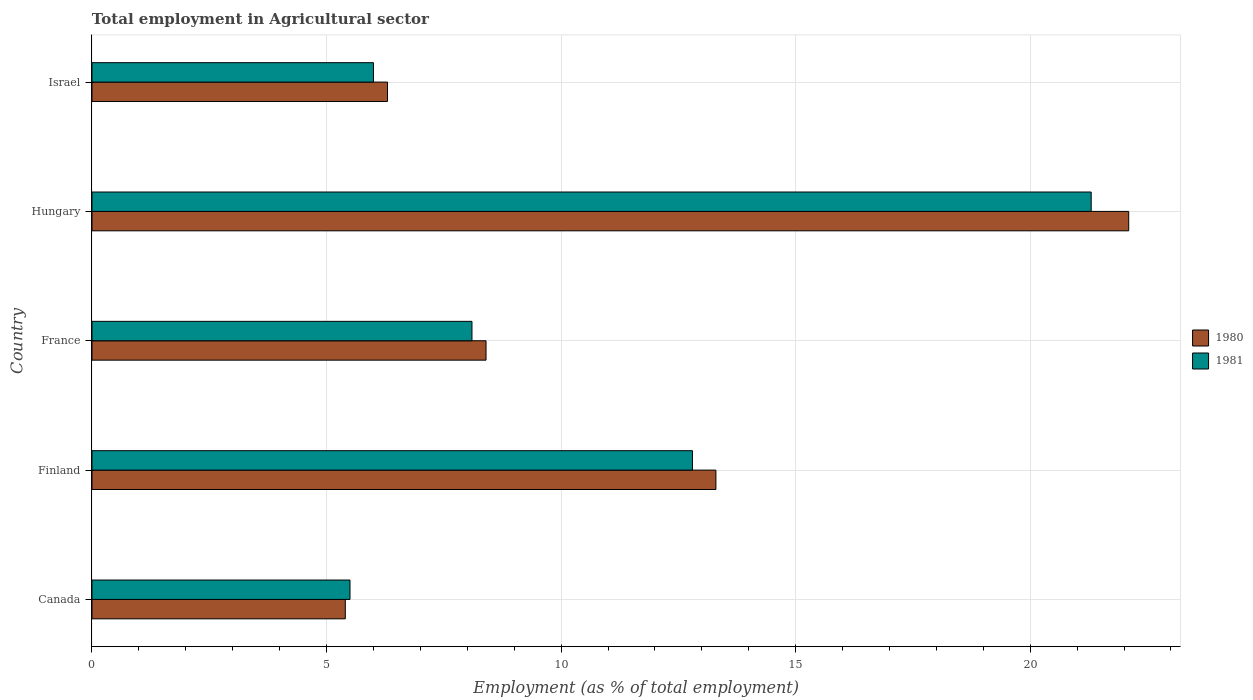How many different coloured bars are there?
Your answer should be very brief. 2. What is the label of the 4th group of bars from the top?
Give a very brief answer. Finland. In how many cases, is the number of bars for a given country not equal to the number of legend labels?
Make the answer very short. 0. What is the employment in agricultural sector in 1981 in Finland?
Give a very brief answer. 12.8. Across all countries, what is the maximum employment in agricultural sector in 1981?
Provide a short and direct response. 21.3. In which country was the employment in agricultural sector in 1981 maximum?
Ensure brevity in your answer.  Hungary. What is the total employment in agricultural sector in 1981 in the graph?
Make the answer very short. 53.7. What is the difference between the employment in agricultural sector in 1981 in France and that in Israel?
Give a very brief answer. 2.1. What is the difference between the employment in agricultural sector in 1980 in Finland and the employment in agricultural sector in 1981 in Hungary?
Provide a succinct answer. -8. What is the average employment in agricultural sector in 1981 per country?
Provide a short and direct response. 10.74. What is the difference between the employment in agricultural sector in 1980 and employment in agricultural sector in 1981 in France?
Provide a short and direct response. 0.3. What is the ratio of the employment in agricultural sector in 1981 in Finland to that in Israel?
Your answer should be very brief. 2.13. What is the difference between the highest and the second highest employment in agricultural sector in 1981?
Ensure brevity in your answer.  8.5. What is the difference between the highest and the lowest employment in agricultural sector in 1981?
Provide a succinct answer. 15.8. Is the sum of the employment in agricultural sector in 1980 in Canada and Israel greater than the maximum employment in agricultural sector in 1981 across all countries?
Make the answer very short. No. What does the 2nd bar from the top in France represents?
Give a very brief answer. 1980. What does the 2nd bar from the bottom in France represents?
Keep it short and to the point. 1981. Are all the bars in the graph horizontal?
Ensure brevity in your answer.  Yes. How many countries are there in the graph?
Make the answer very short. 5. Where does the legend appear in the graph?
Keep it short and to the point. Center right. How many legend labels are there?
Your answer should be compact. 2. What is the title of the graph?
Provide a short and direct response. Total employment in Agricultural sector. Does "1963" appear as one of the legend labels in the graph?
Provide a succinct answer. No. What is the label or title of the X-axis?
Give a very brief answer. Employment (as % of total employment). What is the label or title of the Y-axis?
Offer a terse response. Country. What is the Employment (as % of total employment) in 1980 in Canada?
Give a very brief answer. 5.4. What is the Employment (as % of total employment) of 1981 in Canada?
Keep it short and to the point. 5.5. What is the Employment (as % of total employment) of 1980 in Finland?
Your answer should be very brief. 13.3. What is the Employment (as % of total employment) in 1981 in Finland?
Provide a short and direct response. 12.8. What is the Employment (as % of total employment) of 1980 in France?
Provide a short and direct response. 8.4. What is the Employment (as % of total employment) of 1981 in France?
Your response must be concise. 8.1. What is the Employment (as % of total employment) of 1980 in Hungary?
Provide a short and direct response. 22.1. What is the Employment (as % of total employment) of 1981 in Hungary?
Your response must be concise. 21.3. What is the Employment (as % of total employment) in 1980 in Israel?
Keep it short and to the point. 6.3. Across all countries, what is the maximum Employment (as % of total employment) in 1980?
Your answer should be compact. 22.1. Across all countries, what is the maximum Employment (as % of total employment) of 1981?
Offer a terse response. 21.3. Across all countries, what is the minimum Employment (as % of total employment) in 1980?
Provide a short and direct response. 5.4. What is the total Employment (as % of total employment) of 1980 in the graph?
Make the answer very short. 55.5. What is the total Employment (as % of total employment) in 1981 in the graph?
Offer a very short reply. 53.7. What is the difference between the Employment (as % of total employment) of 1980 in Canada and that in Finland?
Your response must be concise. -7.9. What is the difference between the Employment (as % of total employment) of 1981 in Canada and that in France?
Your answer should be very brief. -2.6. What is the difference between the Employment (as % of total employment) in 1980 in Canada and that in Hungary?
Keep it short and to the point. -16.7. What is the difference between the Employment (as % of total employment) of 1981 in Canada and that in Hungary?
Offer a very short reply. -15.8. What is the difference between the Employment (as % of total employment) of 1980 in Canada and that in Israel?
Ensure brevity in your answer.  -0.9. What is the difference between the Employment (as % of total employment) in 1981 in Canada and that in Israel?
Your answer should be compact. -0.5. What is the difference between the Employment (as % of total employment) of 1980 in Finland and that in France?
Keep it short and to the point. 4.9. What is the difference between the Employment (as % of total employment) in 1981 in Finland and that in France?
Give a very brief answer. 4.7. What is the difference between the Employment (as % of total employment) in 1980 in Finland and that in Hungary?
Ensure brevity in your answer.  -8.8. What is the difference between the Employment (as % of total employment) of 1980 in Finland and that in Israel?
Provide a succinct answer. 7. What is the difference between the Employment (as % of total employment) in 1980 in France and that in Hungary?
Ensure brevity in your answer.  -13.7. What is the difference between the Employment (as % of total employment) of 1980 in France and that in Israel?
Provide a short and direct response. 2.1. What is the difference between the Employment (as % of total employment) in 1981 in France and that in Israel?
Offer a very short reply. 2.1. What is the difference between the Employment (as % of total employment) in 1980 in Canada and the Employment (as % of total employment) in 1981 in Finland?
Your response must be concise. -7.4. What is the difference between the Employment (as % of total employment) of 1980 in Canada and the Employment (as % of total employment) of 1981 in Hungary?
Provide a short and direct response. -15.9. What is the difference between the Employment (as % of total employment) in 1980 in Canada and the Employment (as % of total employment) in 1981 in Israel?
Ensure brevity in your answer.  -0.6. What is the difference between the Employment (as % of total employment) in 1980 in Hungary and the Employment (as % of total employment) in 1981 in Israel?
Offer a terse response. 16.1. What is the average Employment (as % of total employment) of 1980 per country?
Your answer should be compact. 11.1. What is the average Employment (as % of total employment) of 1981 per country?
Offer a very short reply. 10.74. What is the difference between the Employment (as % of total employment) of 1980 and Employment (as % of total employment) of 1981 in Canada?
Give a very brief answer. -0.1. What is the difference between the Employment (as % of total employment) of 1980 and Employment (as % of total employment) of 1981 in Finland?
Offer a very short reply. 0.5. What is the difference between the Employment (as % of total employment) in 1980 and Employment (as % of total employment) in 1981 in France?
Your answer should be compact. 0.3. What is the ratio of the Employment (as % of total employment) in 1980 in Canada to that in Finland?
Provide a short and direct response. 0.41. What is the ratio of the Employment (as % of total employment) of 1981 in Canada to that in Finland?
Offer a terse response. 0.43. What is the ratio of the Employment (as % of total employment) in 1980 in Canada to that in France?
Provide a short and direct response. 0.64. What is the ratio of the Employment (as % of total employment) of 1981 in Canada to that in France?
Offer a terse response. 0.68. What is the ratio of the Employment (as % of total employment) of 1980 in Canada to that in Hungary?
Offer a very short reply. 0.24. What is the ratio of the Employment (as % of total employment) in 1981 in Canada to that in Hungary?
Offer a terse response. 0.26. What is the ratio of the Employment (as % of total employment) of 1981 in Canada to that in Israel?
Give a very brief answer. 0.92. What is the ratio of the Employment (as % of total employment) of 1980 in Finland to that in France?
Provide a succinct answer. 1.58. What is the ratio of the Employment (as % of total employment) of 1981 in Finland to that in France?
Make the answer very short. 1.58. What is the ratio of the Employment (as % of total employment) in 1980 in Finland to that in Hungary?
Make the answer very short. 0.6. What is the ratio of the Employment (as % of total employment) of 1981 in Finland to that in Hungary?
Your answer should be compact. 0.6. What is the ratio of the Employment (as % of total employment) in 1980 in Finland to that in Israel?
Offer a very short reply. 2.11. What is the ratio of the Employment (as % of total employment) in 1981 in Finland to that in Israel?
Your answer should be compact. 2.13. What is the ratio of the Employment (as % of total employment) in 1980 in France to that in Hungary?
Offer a terse response. 0.38. What is the ratio of the Employment (as % of total employment) in 1981 in France to that in Hungary?
Your response must be concise. 0.38. What is the ratio of the Employment (as % of total employment) of 1981 in France to that in Israel?
Ensure brevity in your answer.  1.35. What is the ratio of the Employment (as % of total employment) in 1980 in Hungary to that in Israel?
Your answer should be compact. 3.51. What is the ratio of the Employment (as % of total employment) in 1981 in Hungary to that in Israel?
Your answer should be compact. 3.55. What is the difference between the highest and the second highest Employment (as % of total employment) in 1980?
Your response must be concise. 8.8. What is the difference between the highest and the second highest Employment (as % of total employment) in 1981?
Your answer should be very brief. 8.5. What is the difference between the highest and the lowest Employment (as % of total employment) of 1980?
Keep it short and to the point. 16.7. 